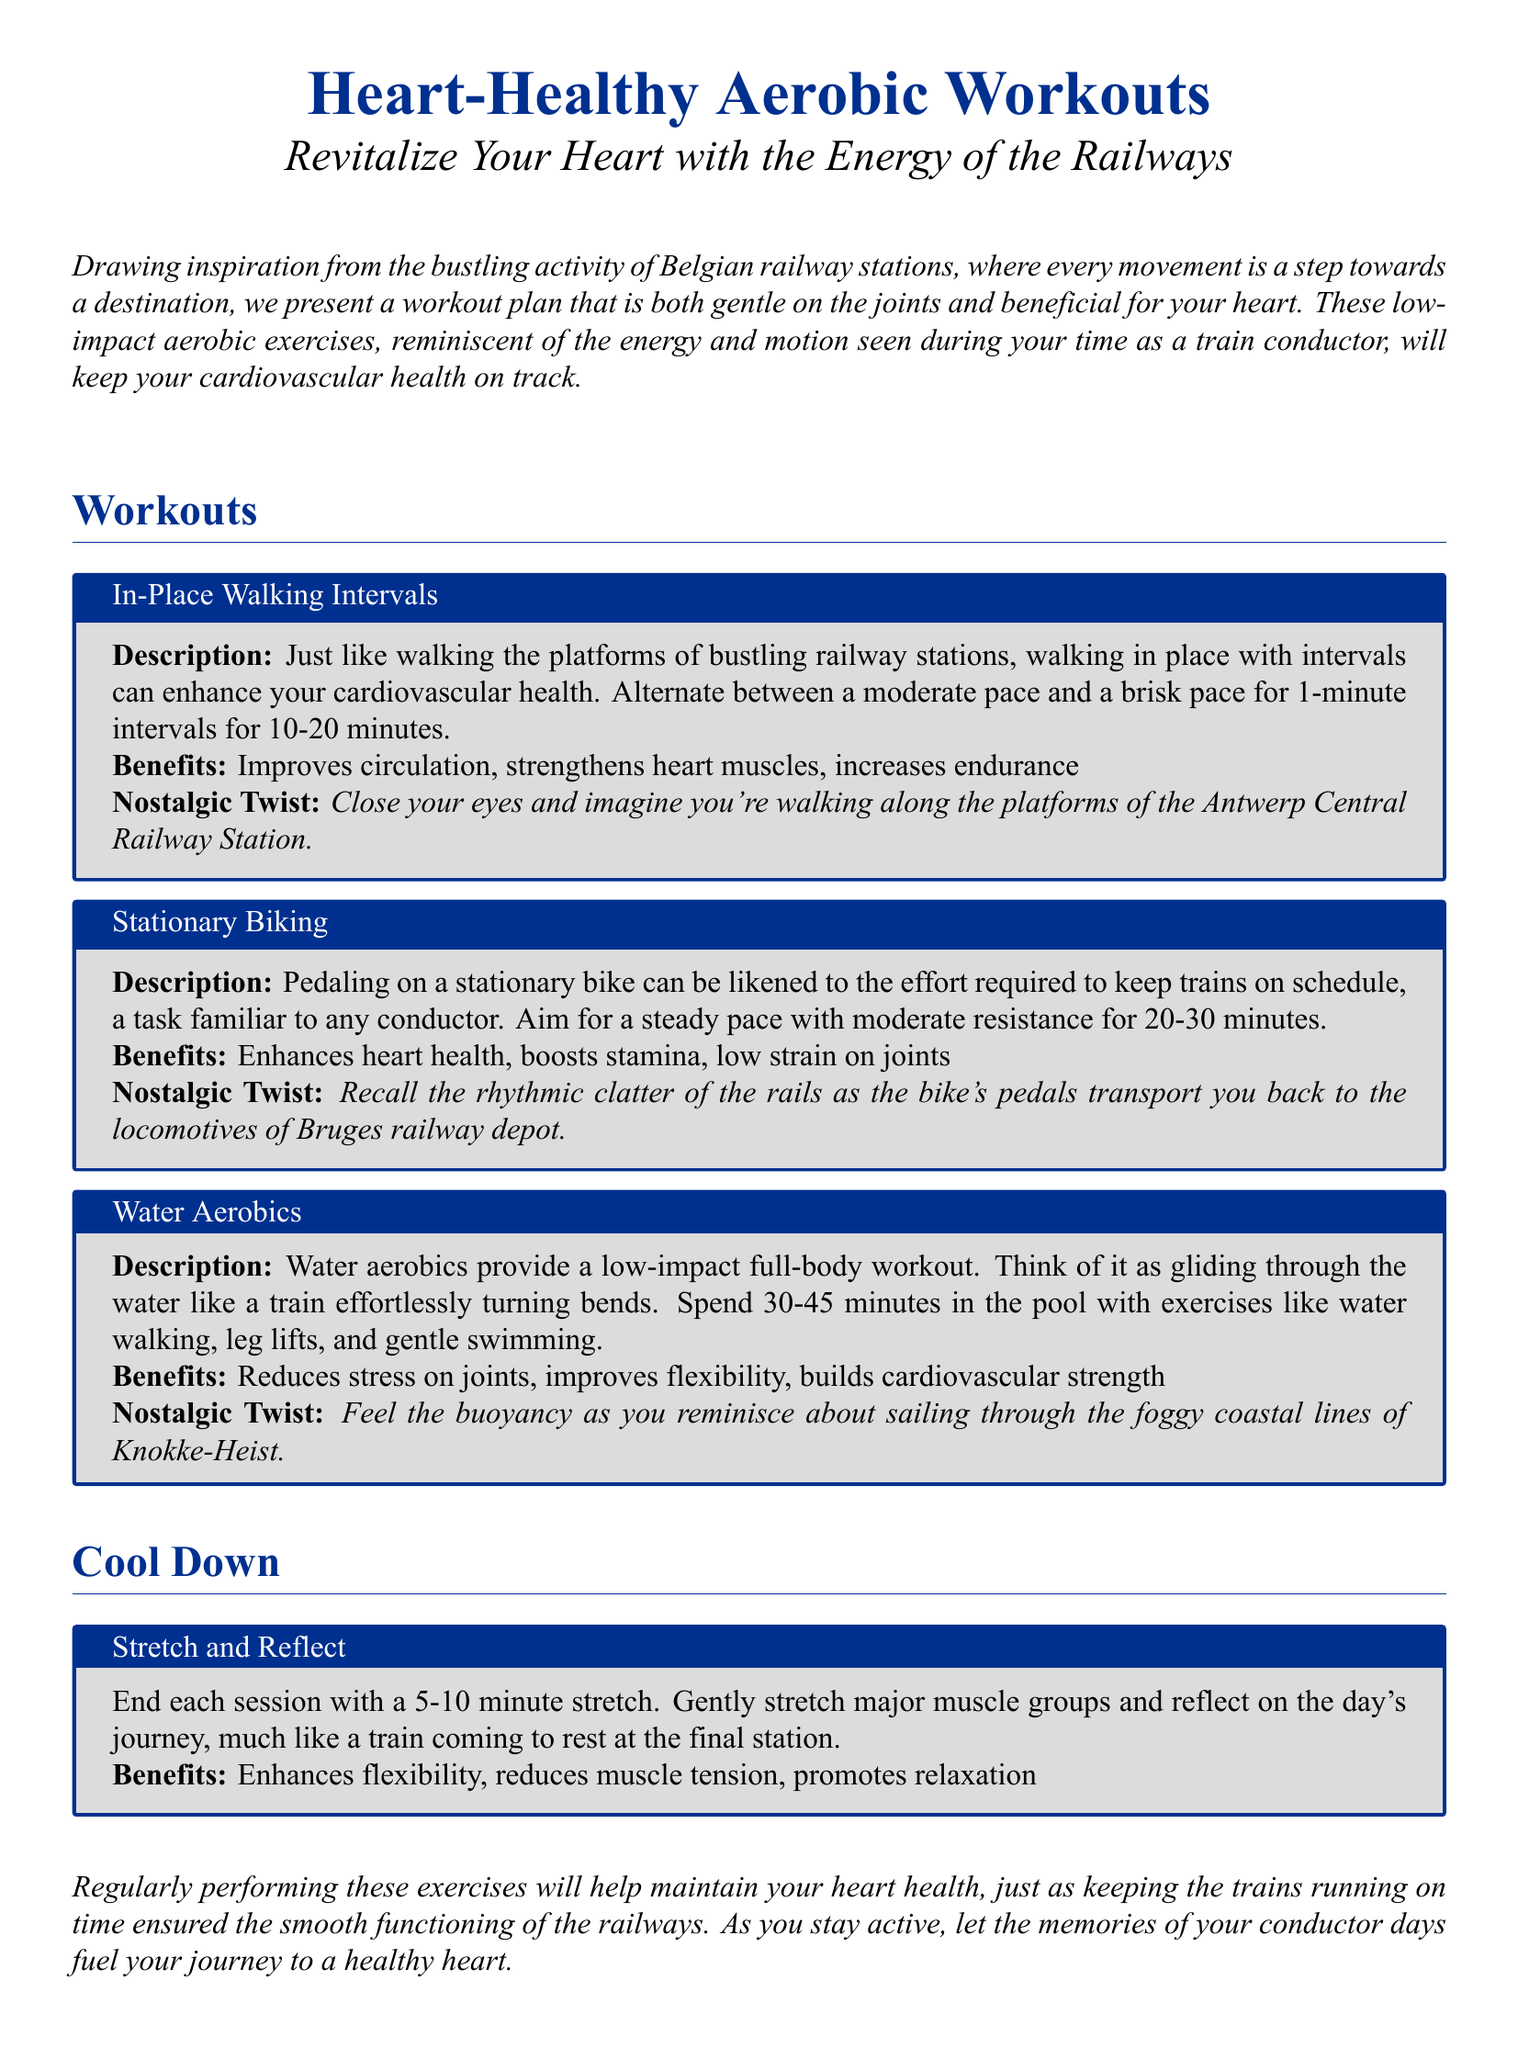What is the title of the document? The title is prominently displayed at the top of the document and states the main topic of focus, which is related to aerobic workouts for heart health.
Answer: Heart-Healthy Aerobic Workouts How long should the stationary biking session last? The document specifies the duration for the stationary biking workout under the benefits section, which provides details on how long to bike.
Answer: 20-30 minutes What type of workouts are mentioned in the plan? The workout types are explicitly listed in the workout section of the document, highlighting the different low-impact aerobic activities.
Answer: In-Place Walking Intervals, Stationary Biking, Water Aerobics What is one benefit of water aerobics? The benefits of water aerobics are described in the workout box dedicated to this exercise, highlighting health advantages.
Answer: Reduces stress on joints What nostalgic imagery is associated with in-place walking intervals? The document includes a visual connection that evokes memories of past experiences while performing this exercise.
Answer: Antwerp Central Railway Station How long should the cool down stretching last? The document outlines the recommended duration for the cool down phase following the exercises, ensuring proper recovery.
Answer: 5-10 minutes What is the main focus of this workout plan? The overarching theme of the document is stated at the beginning, emphasizing the main health goal of the workouts.
Answer: Cardiovascular health What type of document is this? The specific nature or format of the document is evident from its structure and content centered around workout guidelines.
Answer: Workout plan What activity is compared to the effort of keeping trains on schedule? The document draws a direct analogy between a common workout and the responsibilities of a train conductor to make an interesting comparison.
Answer: Stationary Biking 